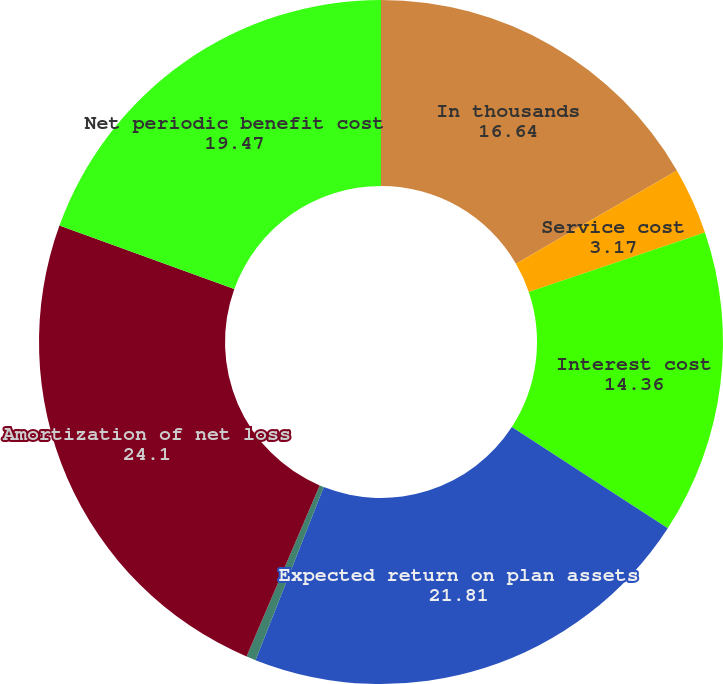<chart> <loc_0><loc_0><loc_500><loc_500><pie_chart><fcel>In thousands<fcel>Service cost<fcel>Interest cost<fcel>Expected return on plan assets<fcel>Amortization of initial net<fcel>Amortization of net loss<fcel>Net periodic benefit cost<nl><fcel>16.64%<fcel>3.17%<fcel>14.36%<fcel>21.81%<fcel>0.45%<fcel>24.1%<fcel>19.47%<nl></chart> 